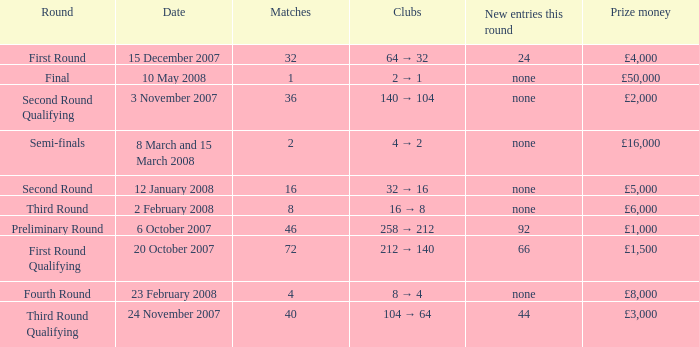How many new entries this round have clubs 2 → 1? None. 